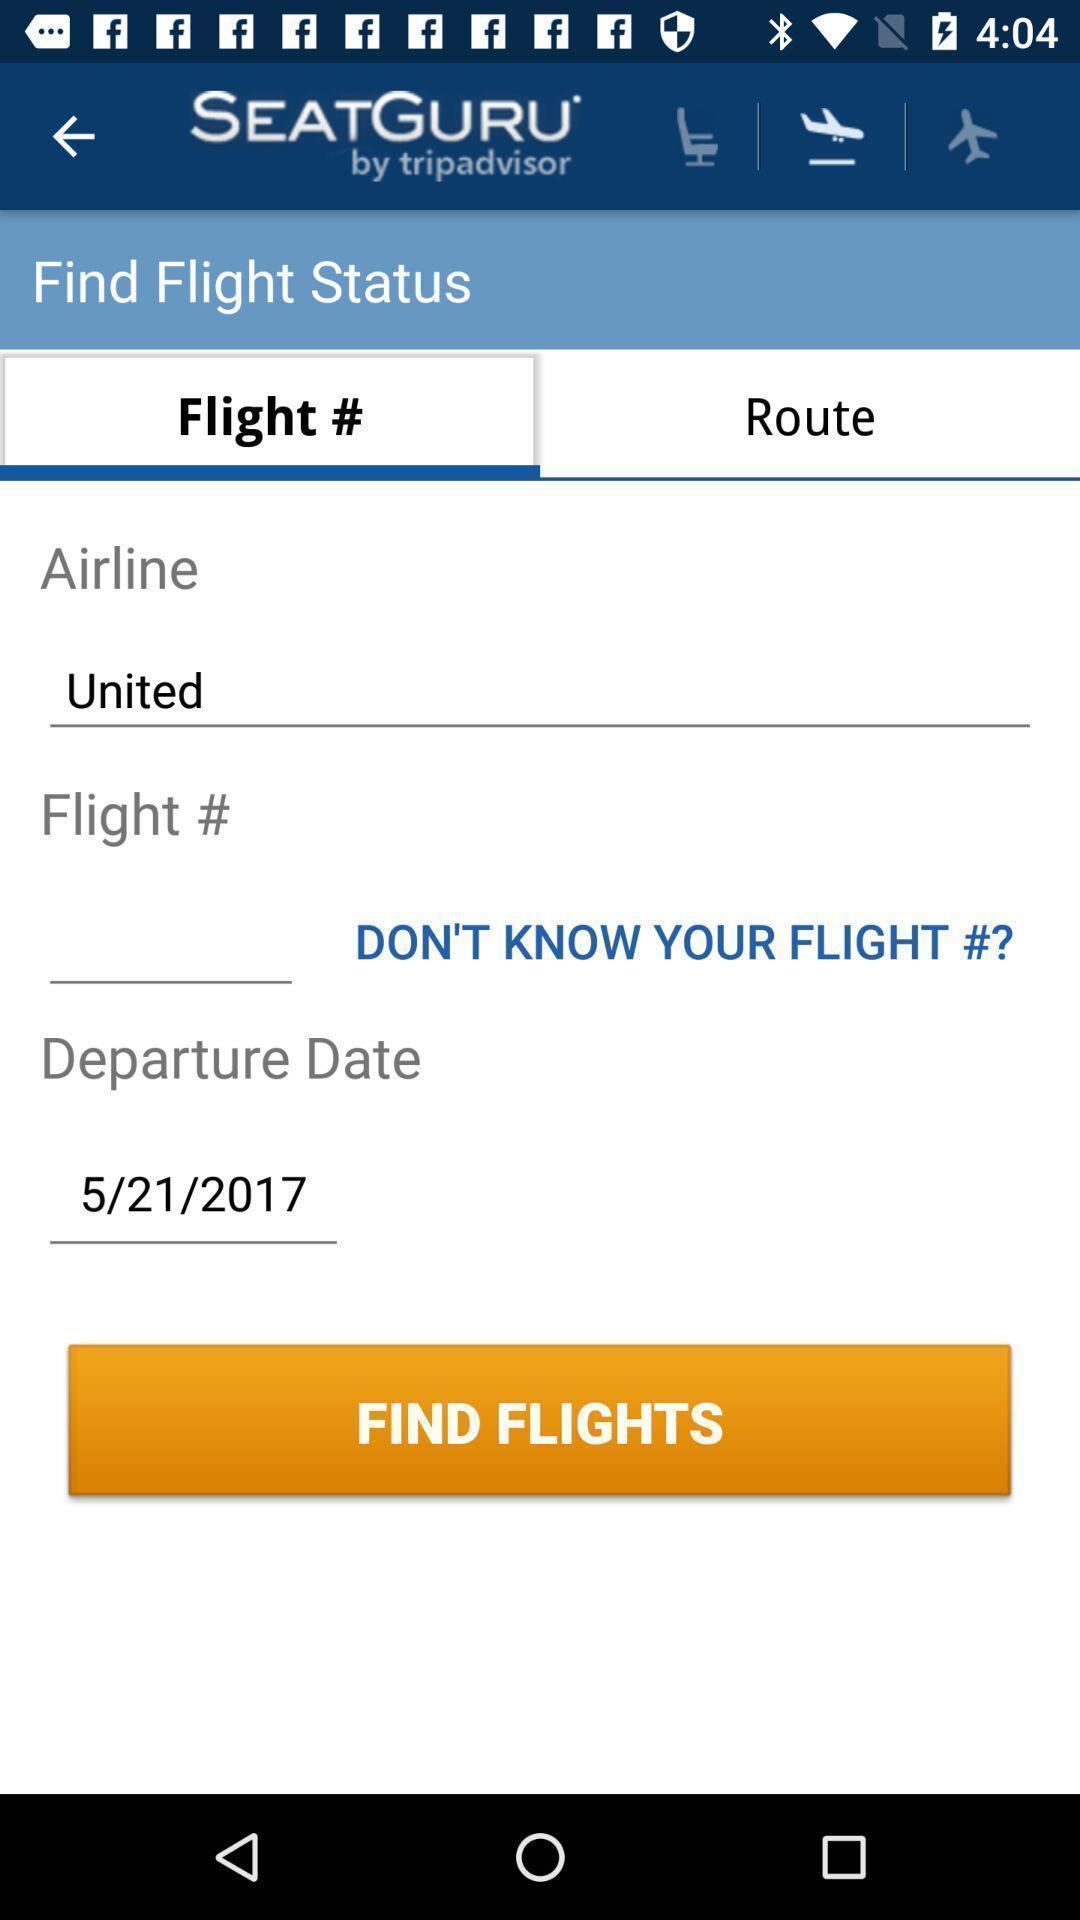Tell me what you see in this picture. Screen shows status about flights. 